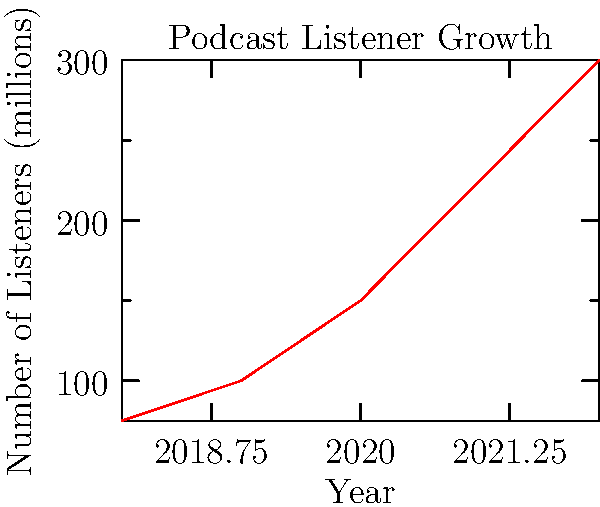Based on the line graph showing the growth of podcast listeners from 2018 to 2022, calculate the compound annual growth rate (CAGR) of the podcast audience. Round your answer to the nearest whole percentage. To calculate the Compound Annual Growth Rate (CAGR), we'll use the formula:

$$ CAGR = \left(\frac{Ending Value}{Beginning Value}\right)^{\frac{1}{n}} - 1 $$

Where:
- Ending Value = 300 million listeners (2022)
- Beginning Value = 75 million listeners (2018)
- n = 4 years (2018 to 2022)

Step 1: Insert the values into the formula
$$ CAGR = \left(\frac{300}{75}\right)^{\frac{1}{4}} - 1 $$

Step 2: Simplify the fraction inside the parentheses
$$ CAGR = (4)^{\frac{1}{4}} - 1 $$

Step 3: Calculate the fourth root of 4
$$ CAGR = 1.4142 - 1 $$

Step 4: Subtract 1
$$ CAGR = 0.4142 $$

Step 5: Convert to a percentage and round to the nearest whole number
$$ CAGR = 41.42\% \approx 41\% $$
Answer: 41% 